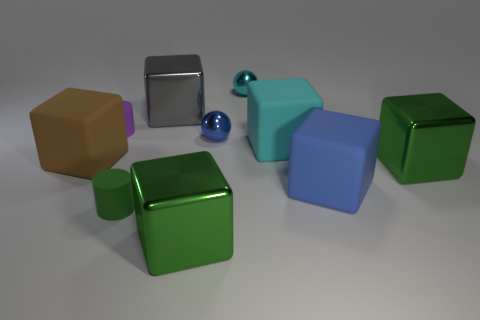What is the shape of the large cyan rubber thing?
Provide a short and direct response. Cube. What shape is the green thing that is the same size as the blue shiny object?
Your response must be concise. Cylinder. There is a big rubber object that is to the left of the cyan metallic sphere; does it have the same shape as the cyan thing in front of the big gray metallic block?
Offer a terse response. Yes. How many objects are either cyan objects that are left of the big cyan cube or things that are right of the green matte cylinder?
Your answer should be very brief. 7. How many other objects are there of the same material as the cyan cube?
Your answer should be very brief. 4. Are the brown cube that is on the left side of the green cylinder and the green cylinder made of the same material?
Make the answer very short. Yes. Are there more metallic spheres that are behind the tiny blue object than small matte cylinders to the left of the large brown cube?
Make the answer very short. Yes. How many objects are cubes that are in front of the green cylinder or metal blocks?
Your answer should be compact. 3. The gray thing that is made of the same material as the small cyan sphere is what shape?
Ensure brevity in your answer.  Cube. Are there any other things that are the same shape as the gray object?
Give a very brief answer. Yes. 